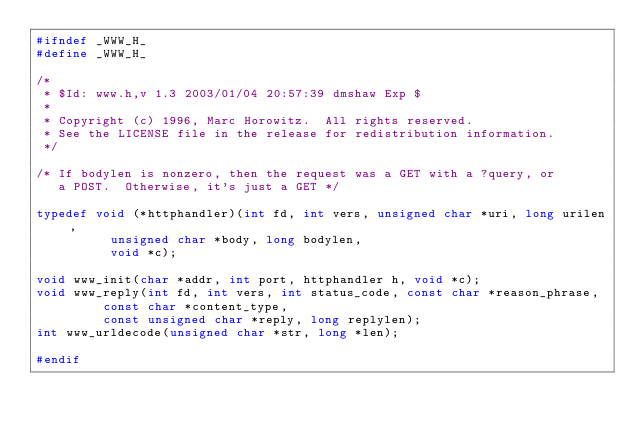Convert code to text. <code><loc_0><loc_0><loc_500><loc_500><_C_>#ifndef _WWW_H_
#define _WWW_H_

/*
 * $Id: www.h,v 1.3 2003/01/04 20:57:39 dmshaw Exp $
 * 
 * Copyright (c) 1996, Marc Horowitz.  All rights reserved.
 * See the LICENSE file in the release for redistribution information.
 */

/* If bodylen is nonzero, then the request was a GET with a ?query, or
   a POST.  Otherwise, it's just a GET */

typedef void (*httphandler)(int fd, int vers, unsigned char *uri, long urilen,
			    unsigned char *body, long bodylen,
			    void *c);

void www_init(char *addr, int port, httphandler h, void *c);
void www_reply(int fd, int vers, int status_code, const char *reason_phrase,
	       const char *content_type,
	       const unsigned char *reply, long replylen);
int www_urldecode(unsigned char *str, long *len);

#endif
</code> 